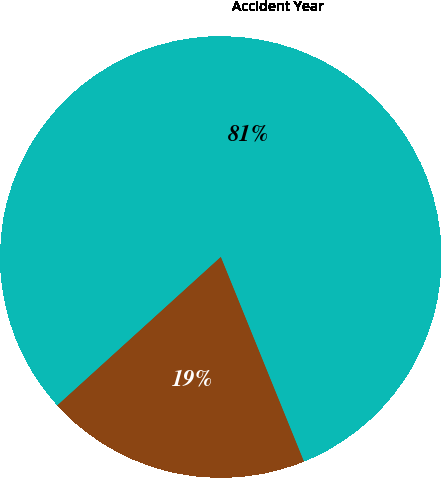Convert chart. <chart><loc_0><loc_0><loc_500><loc_500><pie_chart><fcel>Accident Year<fcel>2007<nl><fcel>80.59%<fcel>19.41%<nl></chart> 